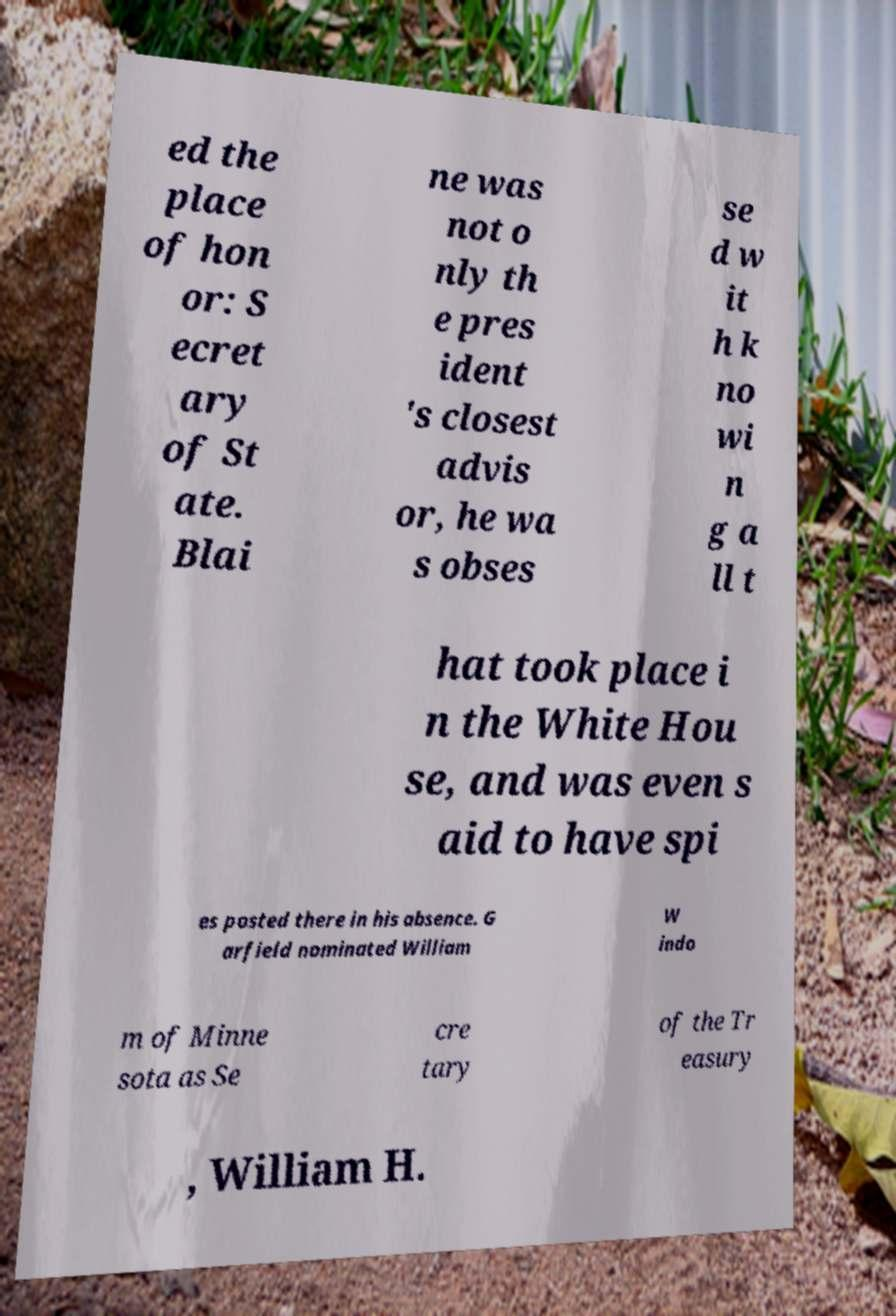There's text embedded in this image that I need extracted. Can you transcribe it verbatim? ed the place of hon or: S ecret ary of St ate. Blai ne was not o nly th e pres ident 's closest advis or, he wa s obses se d w it h k no wi n g a ll t hat took place i n the White Hou se, and was even s aid to have spi es posted there in his absence. G arfield nominated William W indo m of Minne sota as Se cre tary of the Tr easury , William H. 